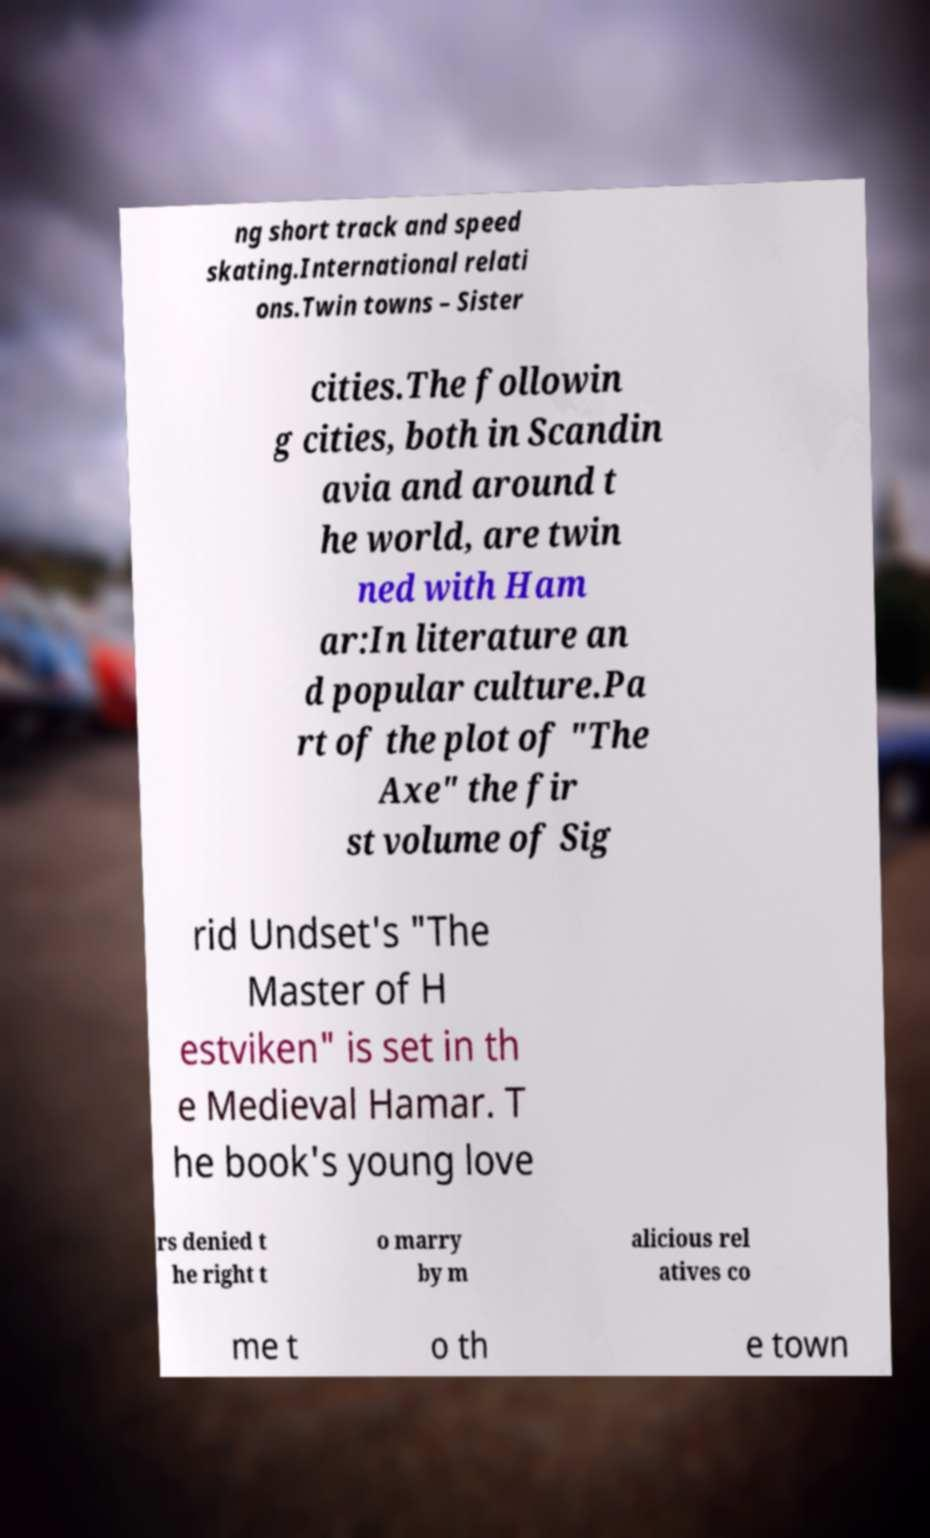Please read and relay the text visible in this image. What does it say? ng short track and speed skating.International relati ons.Twin towns – Sister cities.The followin g cities, both in Scandin avia and around t he world, are twin ned with Ham ar:In literature an d popular culture.Pa rt of the plot of "The Axe" the fir st volume of Sig rid Undset's "The Master of H estviken" is set in th e Medieval Hamar. T he book's young love rs denied t he right t o marry by m alicious rel atives co me t o th e town 